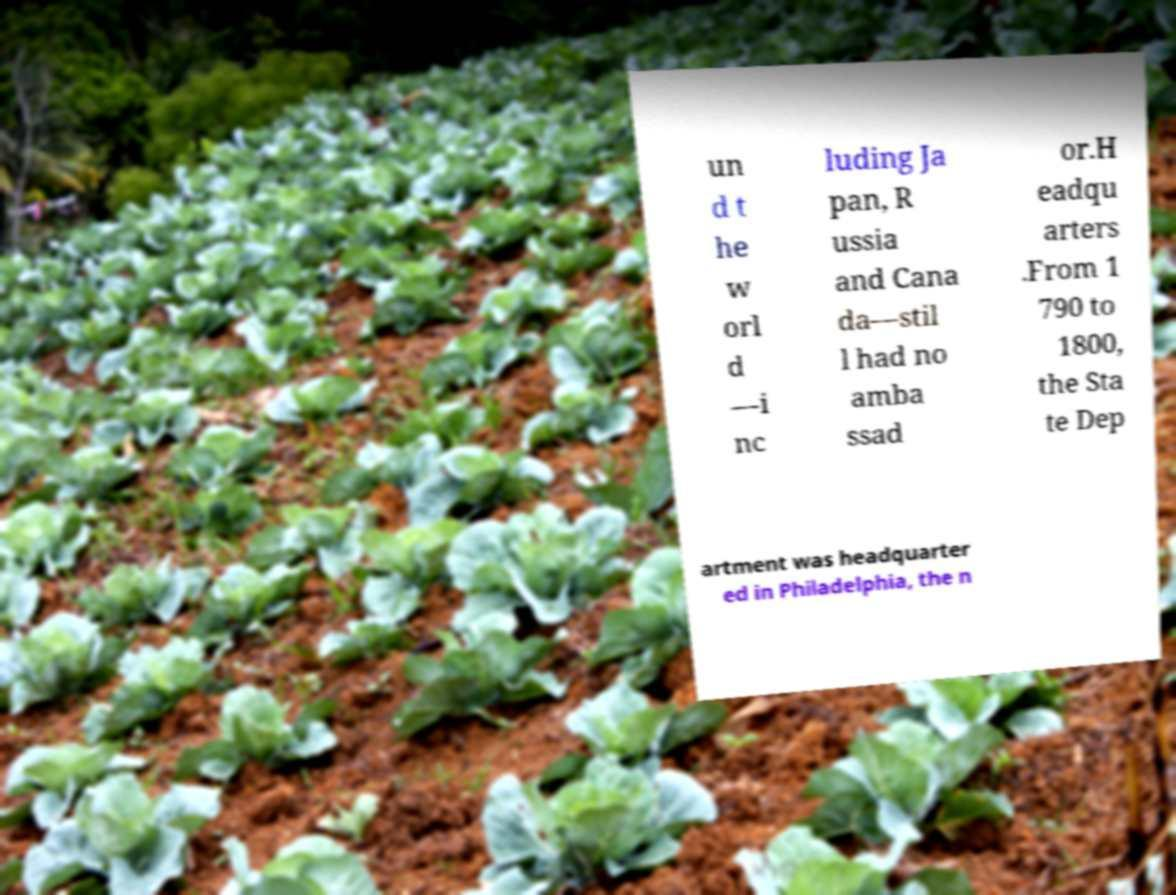Please read and relay the text visible in this image. What does it say? un d t he w orl d —i nc luding Ja pan, R ussia and Cana da—stil l had no amba ssad or.H eadqu arters .From 1 790 to 1800, the Sta te Dep artment was headquarter ed in Philadelphia, the n 